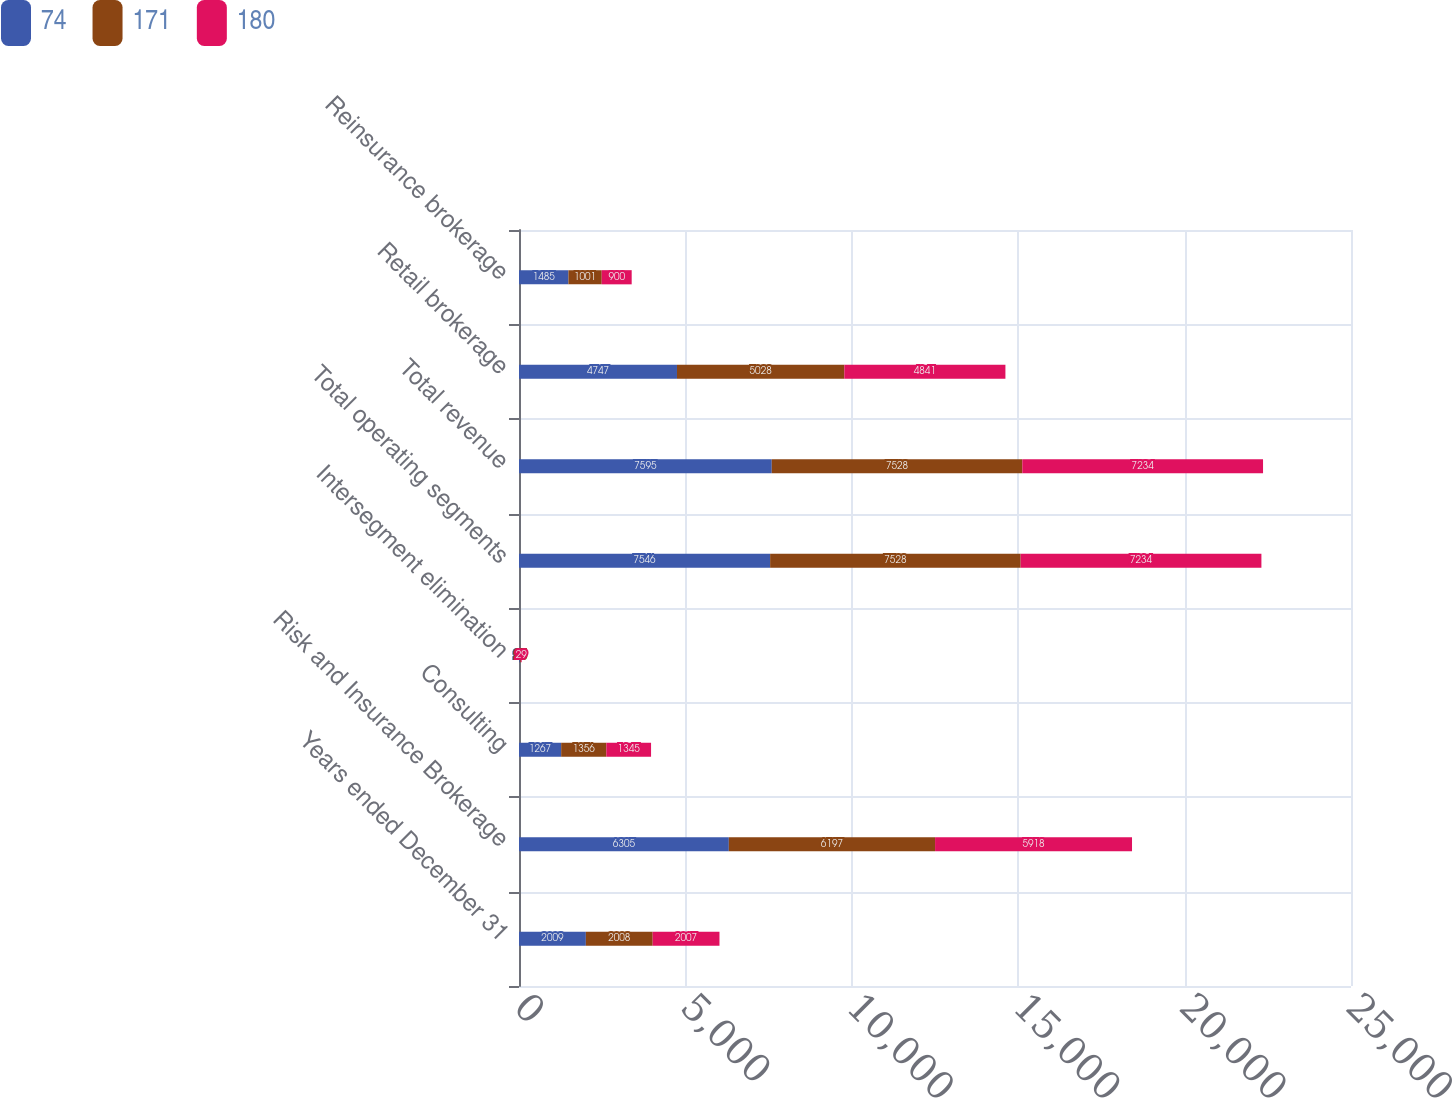Convert chart to OTSL. <chart><loc_0><loc_0><loc_500><loc_500><stacked_bar_chart><ecel><fcel>Years ended December 31<fcel>Risk and Insurance Brokerage<fcel>Consulting<fcel>Intersegment elimination<fcel>Total operating segments<fcel>Total revenue<fcel>Retail brokerage<fcel>Reinsurance brokerage<nl><fcel>74<fcel>2009<fcel>6305<fcel>1267<fcel>26<fcel>7546<fcel>7595<fcel>4747<fcel>1485<nl><fcel>171<fcel>2008<fcel>6197<fcel>1356<fcel>25<fcel>7528<fcel>7528<fcel>5028<fcel>1001<nl><fcel>180<fcel>2007<fcel>5918<fcel>1345<fcel>29<fcel>7234<fcel>7234<fcel>4841<fcel>900<nl></chart> 